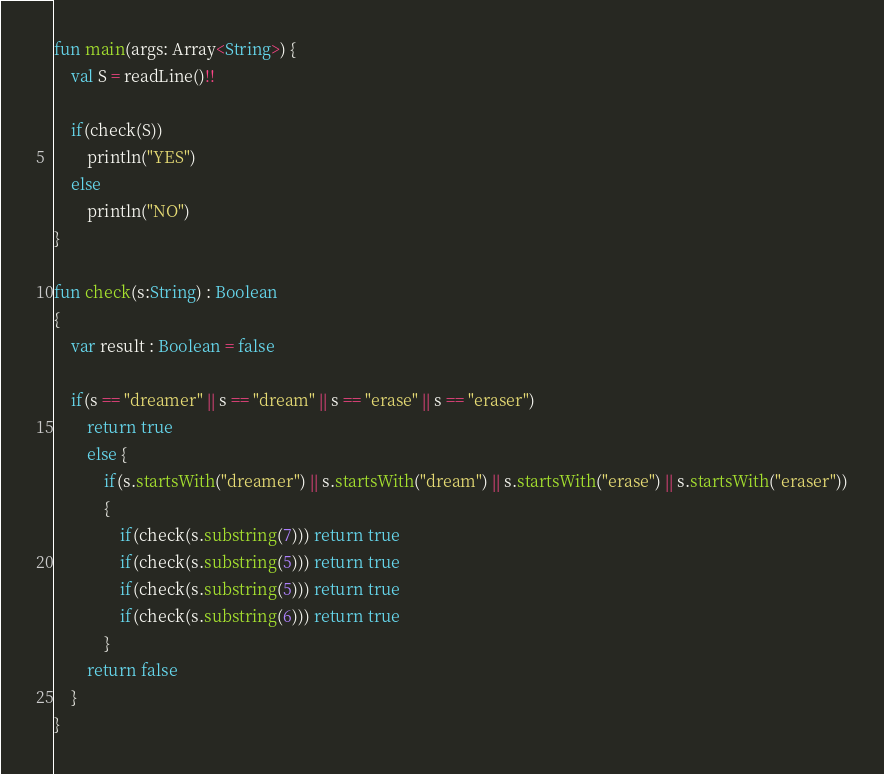<code> <loc_0><loc_0><loc_500><loc_500><_Kotlin_>fun main(args: Array<String>) {
    val S = readLine()!!

    if(check(S))
        println("YES")
    else
        println("NO")
}

fun check(s:String) : Boolean
{
    var result : Boolean = false

    if(s == "dreamer" || s == "dream" || s == "erase" || s == "eraser")
        return true
        else {
            if(s.startsWith("dreamer") || s.startsWith("dream") || s.startsWith("erase") || s.startsWith("eraser"))
            {
                if(check(s.substring(7))) return true
                if(check(s.substring(5))) return true
                if(check(s.substring(5))) return true
                if(check(s.substring(6))) return true
            } 
        return false
    }
}</code> 